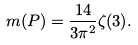Convert formula to latex. <formula><loc_0><loc_0><loc_500><loc_500>m ( P ) = \frac { 1 4 } { 3 \pi ^ { 2 } } \zeta ( 3 ) .</formula> 